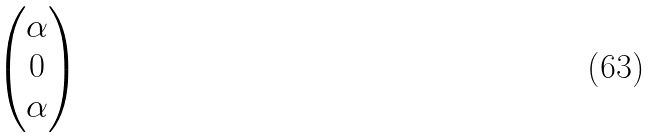<formula> <loc_0><loc_0><loc_500><loc_500>\begin{pmatrix} \alpha \\ 0 \\ \alpha \end{pmatrix}</formula> 